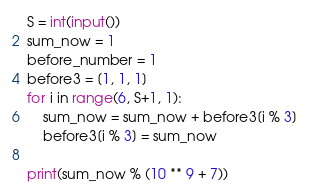Convert code to text. <code><loc_0><loc_0><loc_500><loc_500><_Python_>S = int(input())
sum_now = 1
before_number = 1
before3 = [1, 1, 1]
for i in range(6, S+1, 1):
    sum_now = sum_now + before3[i % 3]
    before3[i % 3] = sum_now

print(sum_now % (10 ** 9 + 7))</code> 